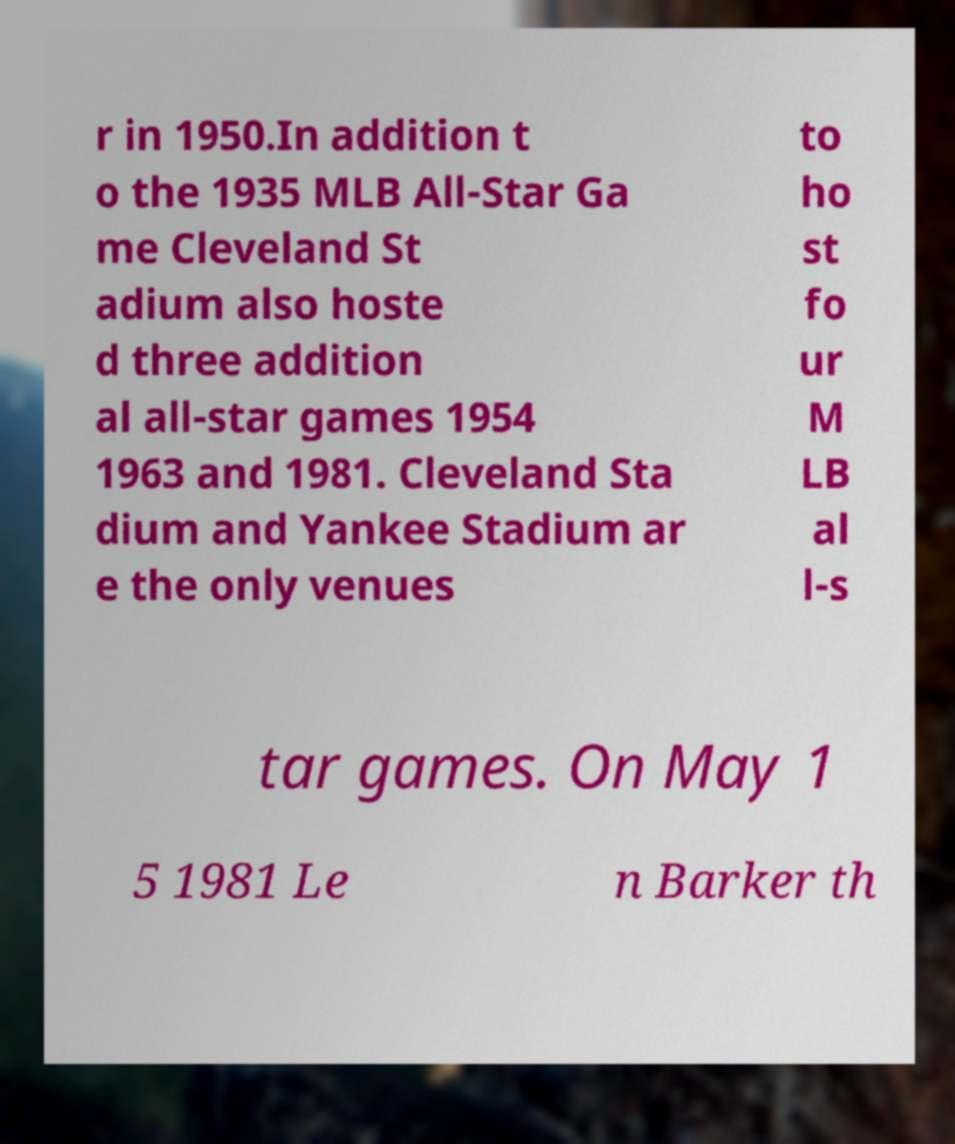Could you assist in decoding the text presented in this image and type it out clearly? r in 1950.In addition t o the 1935 MLB All-Star Ga me Cleveland St adium also hoste d three addition al all-star games 1954 1963 and 1981. Cleveland Sta dium and Yankee Stadium ar e the only venues to ho st fo ur M LB al l-s tar games. On May 1 5 1981 Le n Barker th 